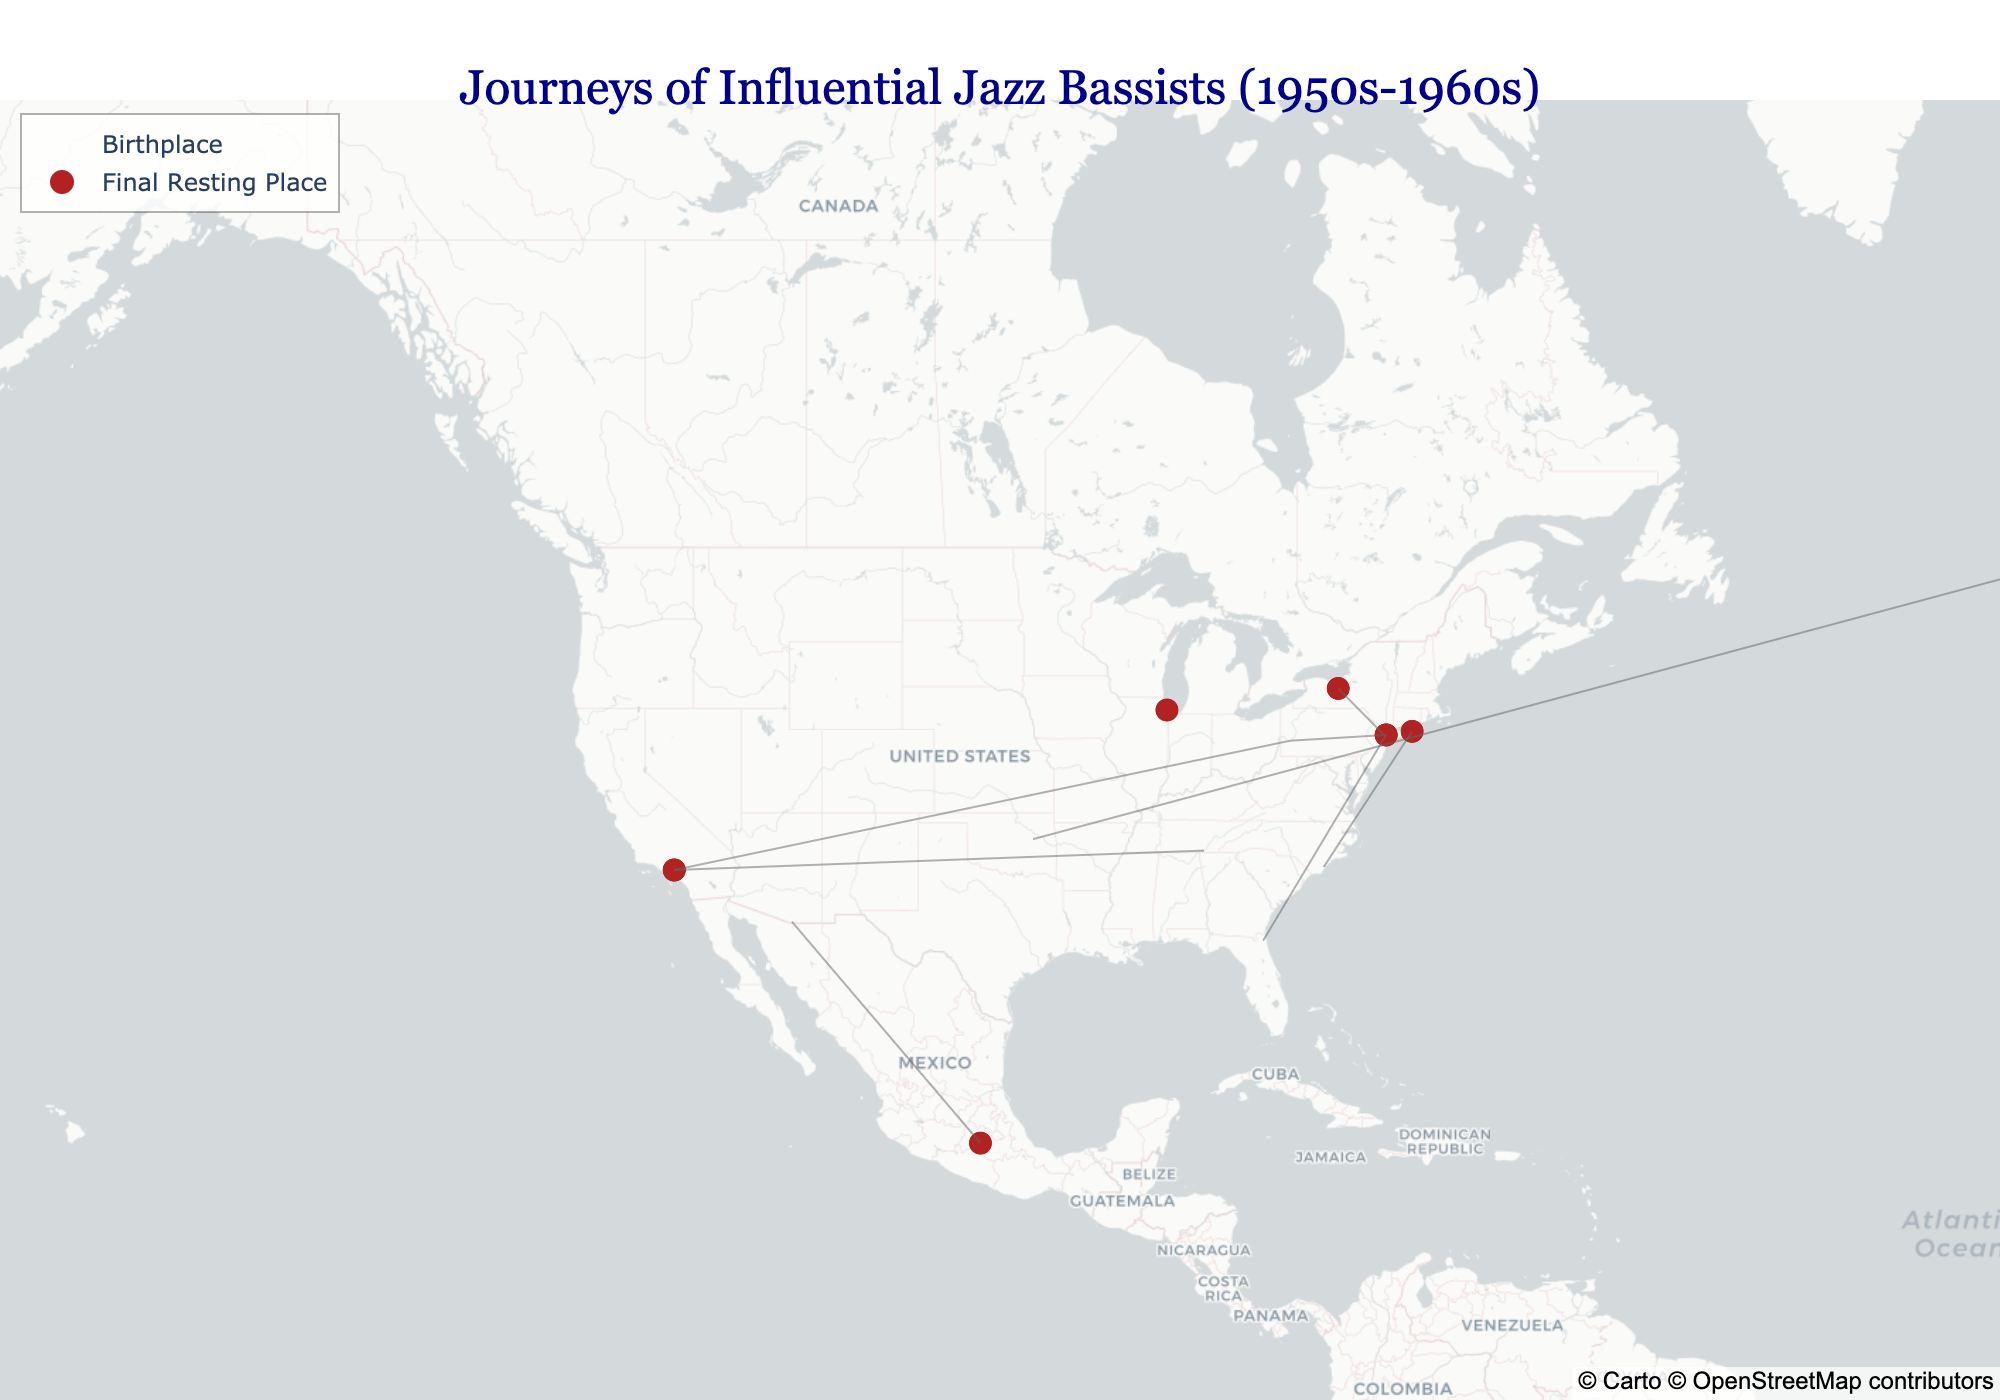What is the title of the plot? The title can be read at the top of the plot. It says: "Journeys of Influential Jazz Bassists (1950s-1960s)."
Answer: Journeys of Influential Jazz Bassists (1950s-1960s) What color are the birthplace markers on the map? The birthplace markers are visually distinct by their color and shape. They are colored royal blue and shaped as stars.
Answer: Royal blue Which city is both the birthplace and final resting place of a bassist? To answer this, find markers for birthplaces and final resting places that overlap in location. Chicago is indicated as both the birthplace and final resting place for Israel Crosby.
Answer: Chicago How many bassists have final resting places outside the United States? Examine the final resting place markers and identify locations that are outside the U.S. Charles Mingus (Cuernavaca), Oscar Pettiford (Copenhagen). This gives us a total of two bassists.
Answer: 2 Which bassist was born in Pittsburgh and where is his final resting place? Locate the birthplace marker in Pittsburgh and trace the line to the final resting place marker. Paul Chambers, who was born in Pittsburgh, has his final resting place in New York City.
Answer: Paul Chambers, New York City Who has the longest geographical distance between their birthplace and final resting place? Compare the distances between paired birthplace and final resting markers. Oscar Pettiford’s journey from Okmulgee (United States) to Copenhagen (Denmark) is the longest notable distance on the map.
Answer: Oscar Pettiford What is a notable feature of Ron Carter's data? Identify and compare the data points for each bassist. Ron Carter has coordinates for his birthplace but lacks final resting place coordinates, indicating he is still alive.
Answer: Still Living Which two bassists share the same final resting place in Los Angeles? Identify and group markers based on shared locations. Ray Brown and Jimmy Blanton both have their final resting place in Los Angeles.
Answer: Ray Brown, Jimmy Blanton How many bassists were born in Pittsburgh? Count the number of birthplace markers located in Pittsburgh. Both Paul Chambers and Ray Brown are born here, making it two bassists.
Answer: 2 Where was Charles Mingus born and where is his final resting place? Look for the birthplace marker for Charles Mingus and trace the line to his final resting place. He was born in Nogales and his final resting place is in Cuernavaca.
Answer: Nogales, Cuernavaca 